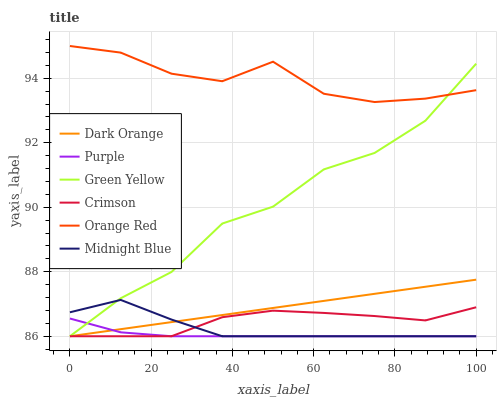Does Purple have the minimum area under the curve?
Answer yes or no. Yes. Does Orange Red have the maximum area under the curve?
Answer yes or no. Yes. Does Midnight Blue have the minimum area under the curve?
Answer yes or no. No. Does Midnight Blue have the maximum area under the curve?
Answer yes or no. No. Is Dark Orange the smoothest?
Answer yes or no. Yes. Is Orange Red the roughest?
Answer yes or no. Yes. Is Midnight Blue the smoothest?
Answer yes or no. No. Is Midnight Blue the roughest?
Answer yes or no. No. Does Dark Orange have the lowest value?
Answer yes or no. Yes. Does Orange Red have the lowest value?
Answer yes or no. No. Does Orange Red have the highest value?
Answer yes or no. Yes. Does Midnight Blue have the highest value?
Answer yes or no. No. Is Midnight Blue less than Orange Red?
Answer yes or no. Yes. Is Orange Red greater than Purple?
Answer yes or no. Yes. Does Crimson intersect Purple?
Answer yes or no. Yes. Is Crimson less than Purple?
Answer yes or no. No. Is Crimson greater than Purple?
Answer yes or no. No. Does Midnight Blue intersect Orange Red?
Answer yes or no. No. 